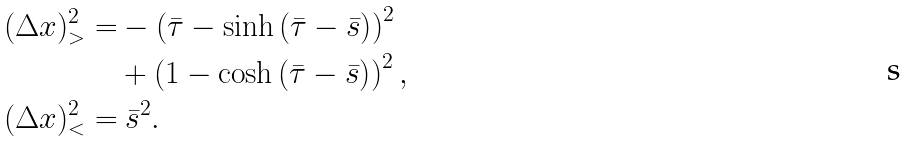<formula> <loc_0><loc_0><loc_500><loc_500>( \Delta x ) ^ { 2 } _ { > } = & - \left ( \bar { \tau } - \sinh \left ( \bar { \tau } - \bar { s } \right ) \right ) ^ { 2 } \\ & + \left ( 1 - \cosh \left ( \bar { \tau } - \bar { s } \right ) \right ) ^ { 2 } , \\ ( \Delta x ) ^ { 2 } _ { < } = & \ \bar { s } ^ { 2 } .</formula> 